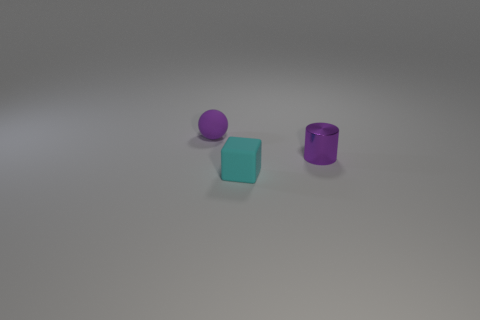Add 3 brown rubber blocks. How many objects exist? 6 Subtract all cylinders. How many objects are left? 2 Add 2 blue spheres. How many blue spheres exist? 2 Subtract 0 gray cylinders. How many objects are left? 3 Subtract all large gray matte cylinders. Subtract all small cyan objects. How many objects are left? 2 Add 3 tiny cylinders. How many tiny cylinders are left? 4 